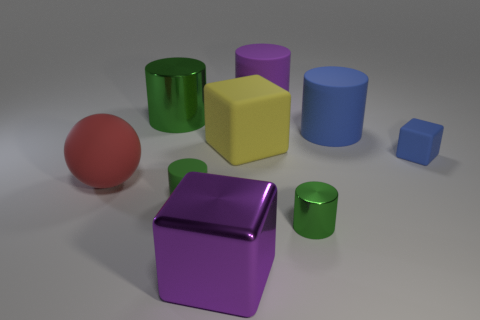Subtract all cyan spheres. How many green cylinders are left? 3 Subtract all purple cylinders. How many cylinders are left? 4 Subtract all tiny rubber cylinders. How many cylinders are left? 4 Subtract all gray cylinders. Subtract all yellow cubes. How many cylinders are left? 5 Subtract all cylinders. How many objects are left? 4 Add 1 tiny blue objects. How many objects exist? 10 Subtract all balls. Subtract all blue blocks. How many objects are left? 7 Add 5 tiny green rubber cylinders. How many tiny green rubber cylinders are left? 6 Add 1 cyan shiny blocks. How many cyan shiny blocks exist? 1 Subtract 0 brown cylinders. How many objects are left? 9 